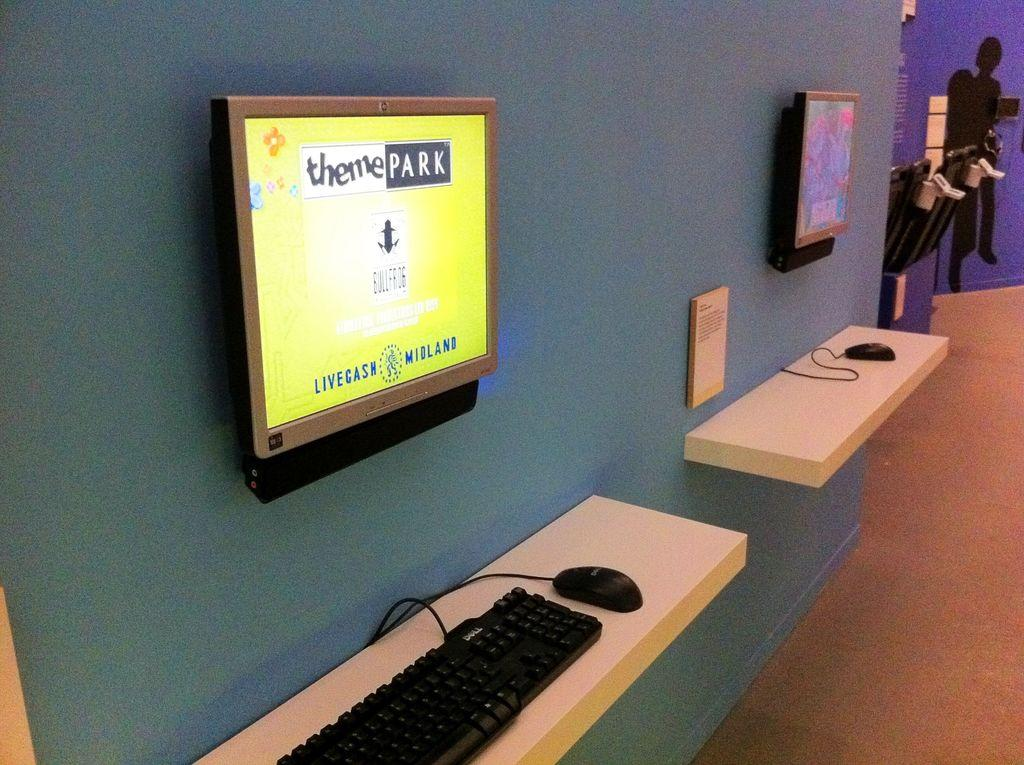<image>
Render a clear and concise summary of the photo. A monitor showing the Theme Park game is on a wall with a keyboard and mouse beneath. 